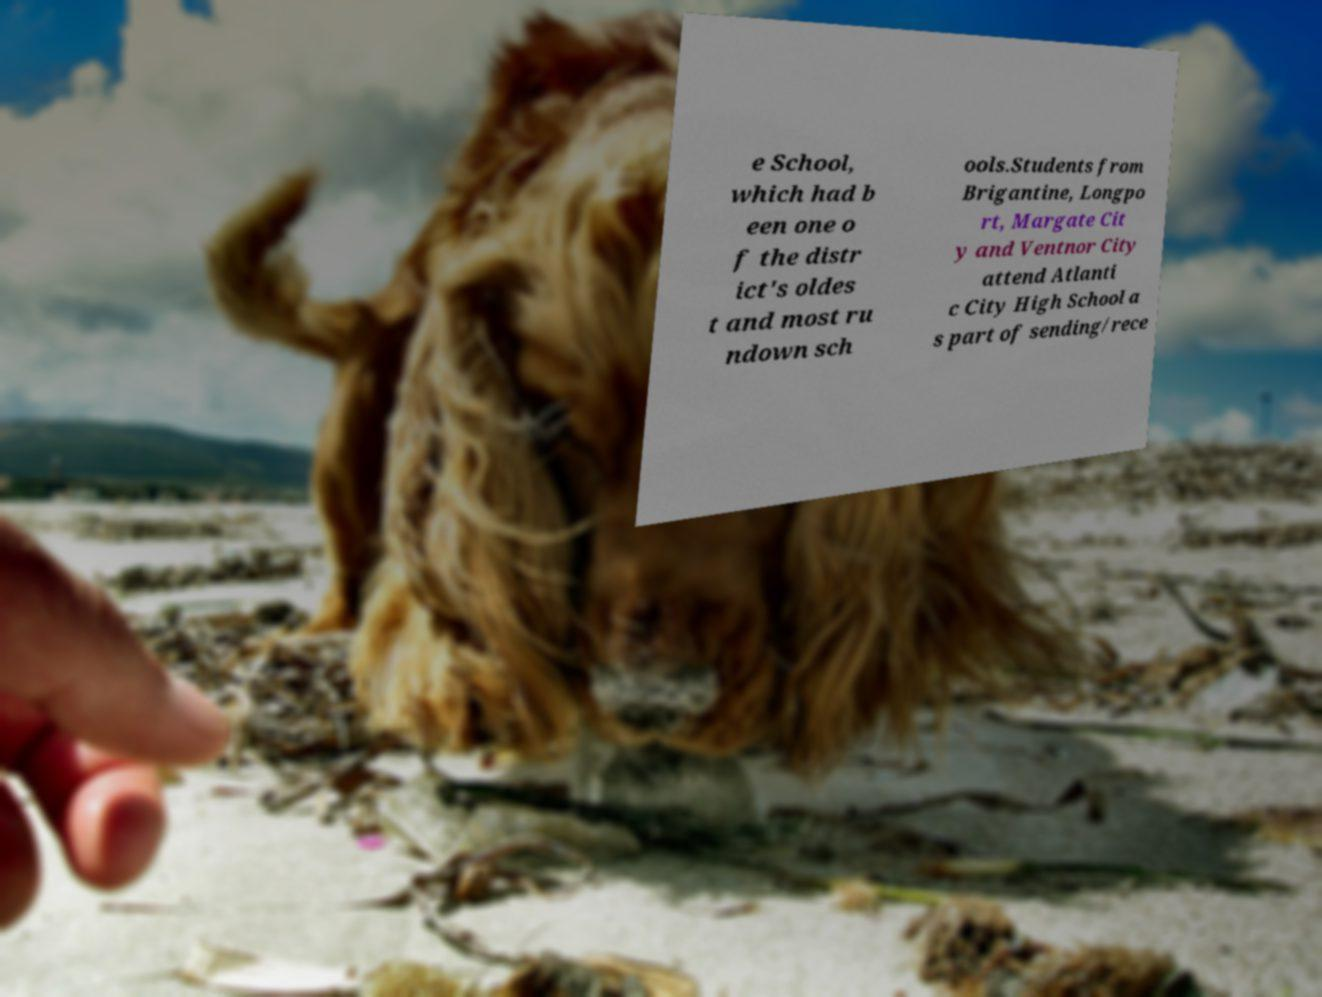Could you extract and type out the text from this image? e School, which had b een one o f the distr ict's oldes t and most ru ndown sch ools.Students from Brigantine, Longpo rt, Margate Cit y and Ventnor City attend Atlanti c City High School a s part of sending/rece 